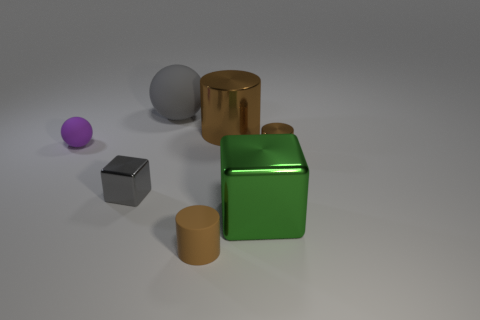Subtract all brown cylinders. How many were subtracted if there are1brown cylinders left? 2 Subtract all small brown cylinders. How many cylinders are left? 1 Subtract all spheres. How many objects are left? 5 Add 2 small brown cubes. How many objects exist? 9 Subtract 0 brown blocks. How many objects are left? 7 Subtract 2 spheres. How many spheres are left? 0 Subtract all blue cylinders. Subtract all red cubes. How many cylinders are left? 3 Subtract all brown blocks. How many gray cylinders are left? 0 Subtract all purple balls. Subtract all small yellow rubber cylinders. How many objects are left? 6 Add 6 large brown shiny objects. How many large brown shiny objects are left? 7 